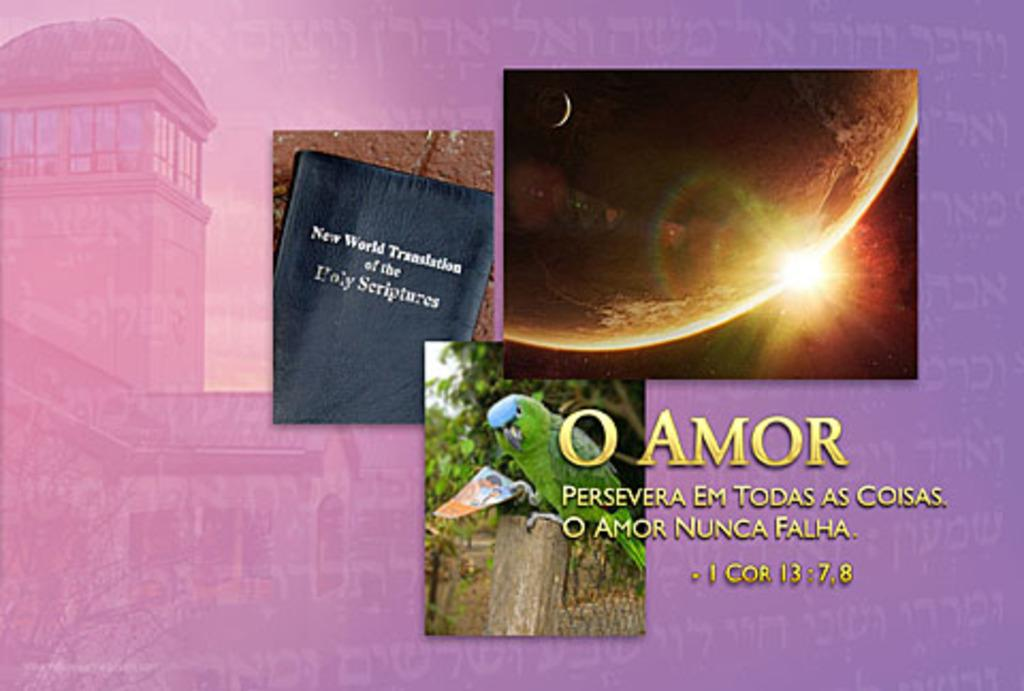<image>
Present a compact description of the photo's key features. Three images are presented with a purple background and one image is a book titled New World Translation of the Holy Scriptures. 